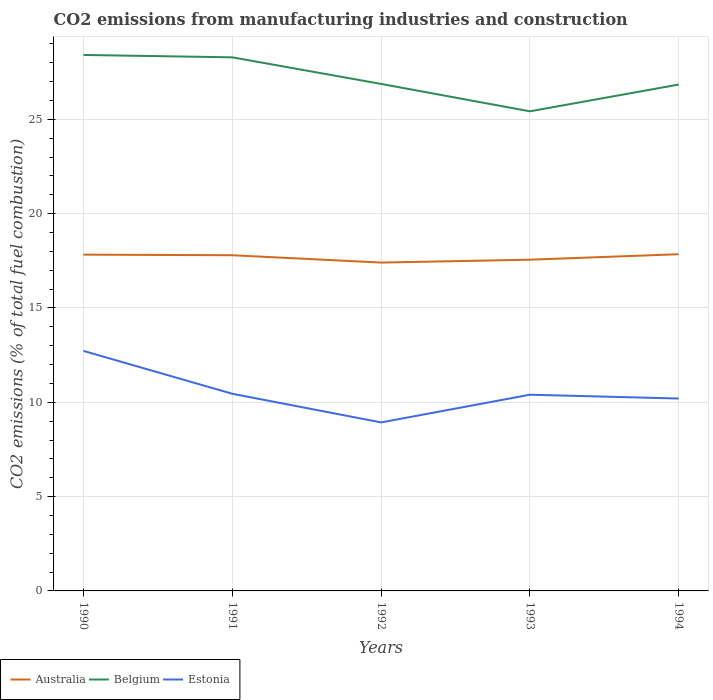Across all years, what is the maximum amount of CO2 emitted in Australia?
Give a very brief answer. 17.41. In which year was the amount of CO2 emitted in Estonia maximum?
Offer a terse response. 1992. What is the total amount of CO2 emitted in Australia in the graph?
Ensure brevity in your answer.  0.39. What is the difference between the highest and the second highest amount of CO2 emitted in Belgium?
Keep it short and to the point. 2.99. What is the difference between the highest and the lowest amount of CO2 emitted in Estonia?
Ensure brevity in your answer.  1. Is the amount of CO2 emitted in Belgium strictly greater than the amount of CO2 emitted in Australia over the years?
Offer a very short reply. No. What is the difference between two consecutive major ticks on the Y-axis?
Provide a short and direct response. 5. Are the values on the major ticks of Y-axis written in scientific E-notation?
Provide a succinct answer. No. Does the graph contain grids?
Provide a short and direct response. Yes. What is the title of the graph?
Offer a terse response. CO2 emissions from manufacturing industries and construction. Does "Kuwait" appear as one of the legend labels in the graph?
Offer a terse response. No. What is the label or title of the X-axis?
Offer a very short reply. Years. What is the label or title of the Y-axis?
Provide a succinct answer. CO2 emissions (% of total fuel combustion). What is the CO2 emissions (% of total fuel combustion) of Australia in 1990?
Keep it short and to the point. 17.83. What is the CO2 emissions (% of total fuel combustion) in Belgium in 1990?
Keep it short and to the point. 28.41. What is the CO2 emissions (% of total fuel combustion) of Estonia in 1990?
Offer a terse response. 12.72. What is the CO2 emissions (% of total fuel combustion) of Australia in 1991?
Give a very brief answer. 17.79. What is the CO2 emissions (% of total fuel combustion) in Belgium in 1991?
Provide a short and direct response. 28.29. What is the CO2 emissions (% of total fuel combustion) of Estonia in 1991?
Give a very brief answer. 10.45. What is the CO2 emissions (% of total fuel combustion) of Australia in 1992?
Provide a succinct answer. 17.41. What is the CO2 emissions (% of total fuel combustion) in Belgium in 1992?
Your answer should be compact. 26.88. What is the CO2 emissions (% of total fuel combustion) of Estonia in 1992?
Your answer should be compact. 8.93. What is the CO2 emissions (% of total fuel combustion) in Australia in 1993?
Provide a succinct answer. 17.56. What is the CO2 emissions (% of total fuel combustion) of Belgium in 1993?
Keep it short and to the point. 25.42. What is the CO2 emissions (% of total fuel combustion) of Estonia in 1993?
Give a very brief answer. 10.4. What is the CO2 emissions (% of total fuel combustion) in Australia in 1994?
Your answer should be compact. 17.85. What is the CO2 emissions (% of total fuel combustion) of Belgium in 1994?
Your response must be concise. 26.84. What is the CO2 emissions (% of total fuel combustion) of Estonia in 1994?
Your response must be concise. 10.2. Across all years, what is the maximum CO2 emissions (% of total fuel combustion) of Australia?
Your answer should be compact. 17.85. Across all years, what is the maximum CO2 emissions (% of total fuel combustion) of Belgium?
Keep it short and to the point. 28.41. Across all years, what is the maximum CO2 emissions (% of total fuel combustion) in Estonia?
Your answer should be compact. 12.72. Across all years, what is the minimum CO2 emissions (% of total fuel combustion) in Australia?
Your answer should be compact. 17.41. Across all years, what is the minimum CO2 emissions (% of total fuel combustion) in Belgium?
Provide a succinct answer. 25.42. Across all years, what is the minimum CO2 emissions (% of total fuel combustion) in Estonia?
Your response must be concise. 8.93. What is the total CO2 emissions (% of total fuel combustion) in Australia in the graph?
Your answer should be compact. 88.43. What is the total CO2 emissions (% of total fuel combustion) in Belgium in the graph?
Ensure brevity in your answer.  135.84. What is the total CO2 emissions (% of total fuel combustion) of Estonia in the graph?
Your answer should be compact. 52.71. What is the difference between the CO2 emissions (% of total fuel combustion) of Australia in 1990 and that in 1991?
Offer a very short reply. 0.03. What is the difference between the CO2 emissions (% of total fuel combustion) of Belgium in 1990 and that in 1991?
Offer a very short reply. 0.13. What is the difference between the CO2 emissions (% of total fuel combustion) in Estonia in 1990 and that in 1991?
Provide a short and direct response. 2.27. What is the difference between the CO2 emissions (% of total fuel combustion) in Australia in 1990 and that in 1992?
Your answer should be very brief. 0.42. What is the difference between the CO2 emissions (% of total fuel combustion) of Belgium in 1990 and that in 1992?
Keep it short and to the point. 1.54. What is the difference between the CO2 emissions (% of total fuel combustion) in Estonia in 1990 and that in 1992?
Your answer should be compact. 3.79. What is the difference between the CO2 emissions (% of total fuel combustion) in Australia in 1990 and that in 1993?
Your response must be concise. 0.27. What is the difference between the CO2 emissions (% of total fuel combustion) of Belgium in 1990 and that in 1993?
Provide a short and direct response. 2.99. What is the difference between the CO2 emissions (% of total fuel combustion) of Estonia in 1990 and that in 1993?
Give a very brief answer. 2.32. What is the difference between the CO2 emissions (% of total fuel combustion) of Australia in 1990 and that in 1994?
Your answer should be compact. -0.02. What is the difference between the CO2 emissions (% of total fuel combustion) of Belgium in 1990 and that in 1994?
Make the answer very short. 1.57. What is the difference between the CO2 emissions (% of total fuel combustion) in Estonia in 1990 and that in 1994?
Your answer should be compact. 2.53. What is the difference between the CO2 emissions (% of total fuel combustion) of Australia in 1991 and that in 1992?
Your response must be concise. 0.39. What is the difference between the CO2 emissions (% of total fuel combustion) of Belgium in 1991 and that in 1992?
Your answer should be compact. 1.41. What is the difference between the CO2 emissions (% of total fuel combustion) of Estonia in 1991 and that in 1992?
Provide a succinct answer. 1.52. What is the difference between the CO2 emissions (% of total fuel combustion) of Australia in 1991 and that in 1993?
Give a very brief answer. 0.24. What is the difference between the CO2 emissions (% of total fuel combustion) in Belgium in 1991 and that in 1993?
Your answer should be compact. 2.86. What is the difference between the CO2 emissions (% of total fuel combustion) in Estonia in 1991 and that in 1993?
Offer a terse response. 0.05. What is the difference between the CO2 emissions (% of total fuel combustion) of Australia in 1991 and that in 1994?
Give a very brief answer. -0.05. What is the difference between the CO2 emissions (% of total fuel combustion) of Belgium in 1991 and that in 1994?
Offer a terse response. 1.44. What is the difference between the CO2 emissions (% of total fuel combustion) of Estonia in 1991 and that in 1994?
Offer a terse response. 0.25. What is the difference between the CO2 emissions (% of total fuel combustion) of Australia in 1992 and that in 1993?
Keep it short and to the point. -0.15. What is the difference between the CO2 emissions (% of total fuel combustion) in Belgium in 1992 and that in 1993?
Your response must be concise. 1.45. What is the difference between the CO2 emissions (% of total fuel combustion) of Estonia in 1992 and that in 1993?
Keep it short and to the point. -1.47. What is the difference between the CO2 emissions (% of total fuel combustion) in Australia in 1992 and that in 1994?
Your answer should be very brief. -0.44. What is the difference between the CO2 emissions (% of total fuel combustion) of Belgium in 1992 and that in 1994?
Your answer should be compact. 0.03. What is the difference between the CO2 emissions (% of total fuel combustion) in Estonia in 1992 and that in 1994?
Ensure brevity in your answer.  -1.27. What is the difference between the CO2 emissions (% of total fuel combustion) of Australia in 1993 and that in 1994?
Give a very brief answer. -0.29. What is the difference between the CO2 emissions (% of total fuel combustion) of Belgium in 1993 and that in 1994?
Offer a terse response. -1.42. What is the difference between the CO2 emissions (% of total fuel combustion) in Estonia in 1993 and that in 1994?
Provide a short and direct response. 0.2. What is the difference between the CO2 emissions (% of total fuel combustion) in Australia in 1990 and the CO2 emissions (% of total fuel combustion) in Belgium in 1991?
Ensure brevity in your answer.  -10.46. What is the difference between the CO2 emissions (% of total fuel combustion) of Australia in 1990 and the CO2 emissions (% of total fuel combustion) of Estonia in 1991?
Your answer should be compact. 7.38. What is the difference between the CO2 emissions (% of total fuel combustion) of Belgium in 1990 and the CO2 emissions (% of total fuel combustion) of Estonia in 1991?
Offer a terse response. 17.96. What is the difference between the CO2 emissions (% of total fuel combustion) of Australia in 1990 and the CO2 emissions (% of total fuel combustion) of Belgium in 1992?
Ensure brevity in your answer.  -9.05. What is the difference between the CO2 emissions (% of total fuel combustion) in Australia in 1990 and the CO2 emissions (% of total fuel combustion) in Estonia in 1992?
Offer a very short reply. 8.89. What is the difference between the CO2 emissions (% of total fuel combustion) of Belgium in 1990 and the CO2 emissions (% of total fuel combustion) of Estonia in 1992?
Your answer should be very brief. 19.48. What is the difference between the CO2 emissions (% of total fuel combustion) in Australia in 1990 and the CO2 emissions (% of total fuel combustion) in Belgium in 1993?
Offer a very short reply. -7.6. What is the difference between the CO2 emissions (% of total fuel combustion) in Australia in 1990 and the CO2 emissions (% of total fuel combustion) in Estonia in 1993?
Provide a succinct answer. 7.43. What is the difference between the CO2 emissions (% of total fuel combustion) in Belgium in 1990 and the CO2 emissions (% of total fuel combustion) in Estonia in 1993?
Your answer should be compact. 18.01. What is the difference between the CO2 emissions (% of total fuel combustion) of Australia in 1990 and the CO2 emissions (% of total fuel combustion) of Belgium in 1994?
Offer a very short reply. -9.02. What is the difference between the CO2 emissions (% of total fuel combustion) of Australia in 1990 and the CO2 emissions (% of total fuel combustion) of Estonia in 1994?
Provide a succinct answer. 7.63. What is the difference between the CO2 emissions (% of total fuel combustion) in Belgium in 1990 and the CO2 emissions (% of total fuel combustion) in Estonia in 1994?
Provide a short and direct response. 18.21. What is the difference between the CO2 emissions (% of total fuel combustion) in Australia in 1991 and the CO2 emissions (% of total fuel combustion) in Belgium in 1992?
Give a very brief answer. -9.08. What is the difference between the CO2 emissions (% of total fuel combustion) of Australia in 1991 and the CO2 emissions (% of total fuel combustion) of Estonia in 1992?
Your response must be concise. 8.86. What is the difference between the CO2 emissions (% of total fuel combustion) in Belgium in 1991 and the CO2 emissions (% of total fuel combustion) in Estonia in 1992?
Offer a very short reply. 19.35. What is the difference between the CO2 emissions (% of total fuel combustion) of Australia in 1991 and the CO2 emissions (% of total fuel combustion) of Belgium in 1993?
Provide a succinct answer. -7.63. What is the difference between the CO2 emissions (% of total fuel combustion) of Australia in 1991 and the CO2 emissions (% of total fuel combustion) of Estonia in 1993?
Offer a very short reply. 7.39. What is the difference between the CO2 emissions (% of total fuel combustion) in Belgium in 1991 and the CO2 emissions (% of total fuel combustion) in Estonia in 1993?
Your answer should be compact. 17.88. What is the difference between the CO2 emissions (% of total fuel combustion) in Australia in 1991 and the CO2 emissions (% of total fuel combustion) in Belgium in 1994?
Your answer should be compact. -9.05. What is the difference between the CO2 emissions (% of total fuel combustion) in Australia in 1991 and the CO2 emissions (% of total fuel combustion) in Estonia in 1994?
Offer a very short reply. 7.6. What is the difference between the CO2 emissions (% of total fuel combustion) in Belgium in 1991 and the CO2 emissions (% of total fuel combustion) in Estonia in 1994?
Ensure brevity in your answer.  18.09. What is the difference between the CO2 emissions (% of total fuel combustion) of Australia in 1992 and the CO2 emissions (% of total fuel combustion) of Belgium in 1993?
Offer a very short reply. -8.02. What is the difference between the CO2 emissions (% of total fuel combustion) of Australia in 1992 and the CO2 emissions (% of total fuel combustion) of Estonia in 1993?
Offer a very short reply. 7.01. What is the difference between the CO2 emissions (% of total fuel combustion) of Belgium in 1992 and the CO2 emissions (% of total fuel combustion) of Estonia in 1993?
Your answer should be very brief. 16.47. What is the difference between the CO2 emissions (% of total fuel combustion) of Australia in 1992 and the CO2 emissions (% of total fuel combustion) of Belgium in 1994?
Your answer should be compact. -9.44. What is the difference between the CO2 emissions (% of total fuel combustion) in Australia in 1992 and the CO2 emissions (% of total fuel combustion) in Estonia in 1994?
Your answer should be compact. 7.21. What is the difference between the CO2 emissions (% of total fuel combustion) in Belgium in 1992 and the CO2 emissions (% of total fuel combustion) in Estonia in 1994?
Ensure brevity in your answer.  16.68. What is the difference between the CO2 emissions (% of total fuel combustion) of Australia in 1993 and the CO2 emissions (% of total fuel combustion) of Belgium in 1994?
Offer a terse response. -9.28. What is the difference between the CO2 emissions (% of total fuel combustion) of Australia in 1993 and the CO2 emissions (% of total fuel combustion) of Estonia in 1994?
Your answer should be very brief. 7.36. What is the difference between the CO2 emissions (% of total fuel combustion) of Belgium in 1993 and the CO2 emissions (% of total fuel combustion) of Estonia in 1994?
Ensure brevity in your answer.  15.23. What is the average CO2 emissions (% of total fuel combustion) in Australia per year?
Your answer should be compact. 17.69. What is the average CO2 emissions (% of total fuel combustion) of Belgium per year?
Your answer should be compact. 27.17. What is the average CO2 emissions (% of total fuel combustion) in Estonia per year?
Offer a terse response. 10.54. In the year 1990, what is the difference between the CO2 emissions (% of total fuel combustion) in Australia and CO2 emissions (% of total fuel combustion) in Belgium?
Your response must be concise. -10.59. In the year 1990, what is the difference between the CO2 emissions (% of total fuel combustion) of Australia and CO2 emissions (% of total fuel combustion) of Estonia?
Offer a terse response. 5.1. In the year 1990, what is the difference between the CO2 emissions (% of total fuel combustion) of Belgium and CO2 emissions (% of total fuel combustion) of Estonia?
Provide a short and direct response. 15.69. In the year 1991, what is the difference between the CO2 emissions (% of total fuel combustion) in Australia and CO2 emissions (% of total fuel combustion) in Belgium?
Give a very brief answer. -10.49. In the year 1991, what is the difference between the CO2 emissions (% of total fuel combustion) in Australia and CO2 emissions (% of total fuel combustion) in Estonia?
Your answer should be very brief. 7.34. In the year 1991, what is the difference between the CO2 emissions (% of total fuel combustion) in Belgium and CO2 emissions (% of total fuel combustion) in Estonia?
Your response must be concise. 17.83. In the year 1992, what is the difference between the CO2 emissions (% of total fuel combustion) of Australia and CO2 emissions (% of total fuel combustion) of Belgium?
Your answer should be very brief. -9.47. In the year 1992, what is the difference between the CO2 emissions (% of total fuel combustion) of Australia and CO2 emissions (% of total fuel combustion) of Estonia?
Provide a succinct answer. 8.47. In the year 1992, what is the difference between the CO2 emissions (% of total fuel combustion) in Belgium and CO2 emissions (% of total fuel combustion) in Estonia?
Offer a very short reply. 17.94. In the year 1993, what is the difference between the CO2 emissions (% of total fuel combustion) of Australia and CO2 emissions (% of total fuel combustion) of Belgium?
Offer a terse response. -7.87. In the year 1993, what is the difference between the CO2 emissions (% of total fuel combustion) in Australia and CO2 emissions (% of total fuel combustion) in Estonia?
Give a very brief answer. 7.16. In the year 1993, what is the difference between the CO2 emissions (% of total fuel combustion) of Belgium and CO2 emissions (% of total fuel combustion) of Estonia?
Provide a short and direct response. 15.02. In the year 1994, what is the difference between the CO2 emissions (% of total fuel combustion) of Australia and CO2 emissions (% of total fuel combustion) of Belgium?
Your answer should be compact. -8.99. In the year 1994, what is the difference between the CO2 emissions (% of total fuel combustion) of Australia and CO2 emissions (% of total fuel combustion) of Estonia?
Offer a terse response. 7.65. In the year 1994, what is the difference between the CO2 emissions (% of total fuel combustion) of Belgium and CO2 emissions (% of total fuel combustion) of Estonia?
Give a very brief answer. 16.64. What is the ratio of the CO2 emissions (% of total fuel combustion) of Estonia in 1990 to that in 1991?
Keep it short and to the point. 1.22. What is the ratio of the CO2 emissions (% of total fuel combustion) in Australia in 1990 to that in 1992?
Offer a terse response. 1.02. What is the ratio of the CO2 emissions (% of total fuel combustion) of Belgium in 1990 to that in 1992?
Ensure brevity in your answer.  1.06. What is the ratio of the CO2 emissions (% of total fuel combustion) of Estonia in 1990 to that in 1992?
Provide a short and direct response. 1.42. What is the ratio of the CO2 emissions (% of total fuel combustion) of Australia in 1990 to that in 1993?
Provide a succinct answer. 1.02. What is the ratio of the CO2 emissions (% of total fuel combustion) of Belgium in 1990 to that in 1993?
Your answer should be compact. 1.12. What is the ratio of the CO2 emissions (% of total fuel combustion) of Estonia in 1990 to that in 1993?
Offer a very short reply. 1.22. What is the ratio of the CO2 emissions (% of total fuel combustion) in Australia in 1990 to that in 1994?
Offer a terse response. 1. What is the ratio of the CO2 emissions (% of total fuel combustion) in Belgium in 1990 to that in 1994?
Your answer should be compact. 1.06. What is the ratio of the CO2 emissions (% of total fuel combustion) in Estonia in 1990 to that in 1994?
Provide a short and direct response. 1.25. What is the ratio of the CO2 emissions (% of total fuel combustion) in Australia in 1991 to that in 1992?
Keep it short and to the point. 1.02. What is the ratio of the CO2 emissions (% of total fuel combustion) of Belgium in 1991 to that in 1992?
Your response must be concise. 1.05. What is the ratio of the CO2 emissions (% of total fuel combustion) of Estonia in 1991 to that in 1992?
Your answer should be very brief. 1.17. What is the ratio of the CO2 emissions (% of total fuel combustion) of Australia in 1991 to that in 1993?
Keep it short and to the point. 1.01. What is the ratio of the CO2 emissions (% of total fuel combustion) in Belgium in 1991 to that in 1993?
Make the answer very short. 1.11. What is the ratio of the CO2 emissions (% of total fuel combustion) in Australia in 1991 to that in 1994?
Keep it short and to the point. 1. What is the ratio of the CO2 emissions (% of total fuel combustion) of Belgium in 1991 to that in 1994?
Your response must be concise. 1.05. What is the ratio of the CO2 emissions (% of total fuel combustion) of Estonia in 1991 to that in 1994?
Provide a short and direct response. 1.02. What is the ratio of the CO2 emissions (% of total fuel combustion) in Australia in 1992 to that in 1993?
Provide a succinct answer. 0.99. What is the ratio of the CO2 emissions (% of total fuel combustion) of Belgium in 1992 to that in 1993?
Provide a short and direct response. 1.06. What is the ratio of the CO2 emissions (% of total fuel combustion) in Estonia in 1992 to that in 1993?
Offer a terse response. 0.86. What is the ratio of the CO2 emissions (% of total fuel combustion) of Australia in 1992 to that in 1994?
Offer a very short reply. 0.98. What is the ratio of the CO2 emissions (% of total fuel combustion) of Estonia in 1992 to that in 1994?
Provide a short and direct response. 0.88. What is the ratio of the CO2 emissions (% of total fuel combustion) in Australia in 1993 to that in 1994?
Your response must be concise. 0.98. What is the ratio of the CO2 emissions (% of total fuel combustion) in Belgium in 1993 to that in 1994?
Your answer should be very brief. 0.95. What is the ratio of the CO2 emissions (% of total fuel combustion) of Estonia in 1993 to that in 1994?
Give a very brief answer. 1.02. What is the difference between the highest and the second highest CO2 emissions (% of total fuel combustion) in Australia?
Keep it short and to the point. 0.02. What is the difference between the highest and the second highest CO2 emissions (% of total fuel combustion) in Belgium?
Offer a very short reply. 0.13. What is the difference between the highest and the second highest CO2 emissions (% of total fuel combustion) of Estonia?
Your answer should be compact. 2.27. What is the difference between the highest and the lowest CO2 emissions (% of total fuel combustion) of Australia?
Offer a terse response. 0.44. What is the difference between the highest and the lowest CO2 emissions (% of total fuel combustion) of Belgium?
Offer a terse response. 2.99. What is the difference between the highest and the lowest CO2 emissions (% of total fuel combustion) of Estonia?
Your response must be concise. 3.79. 